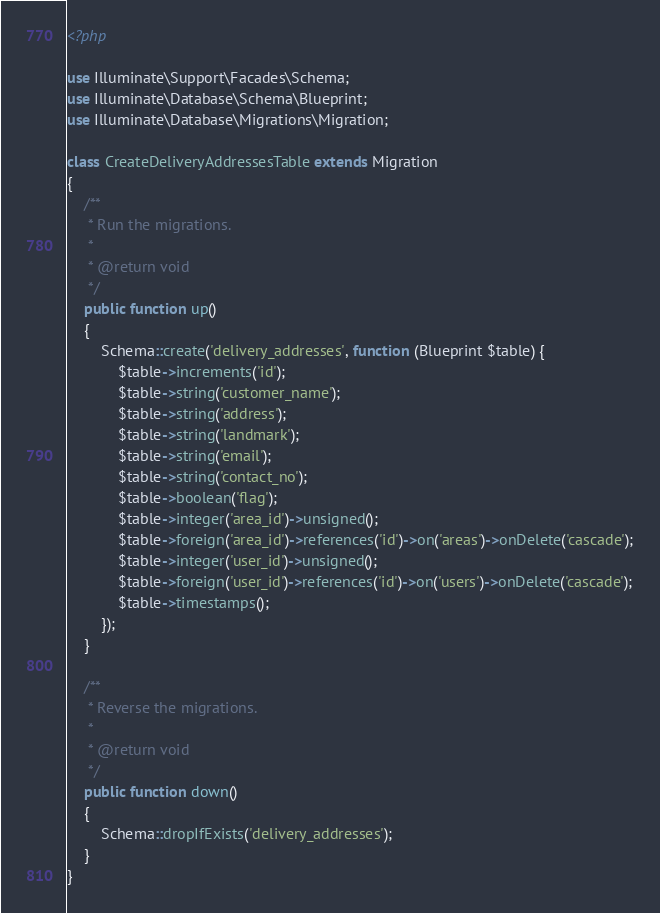<code> <loc_0><loc_0><loc_500><loc_500><_PHP_><?php

use Illuminate\Support\Facades\Schema;
use Illuminate\Database\Schema\Blueprint;
use Illuminate\Database\Migrations\Migration;

class CreateDeliveryAddressesTable extends Migration
{
    /**
     * Run the migrations.
     *
     * @return void
     */
    public function up()
    {
        Schema::create('delivery_addresses', function (Blueprint $table) {
            $table->increments('id');
            $table->string('customer_name');
            $table->string('address');
            $table->string('landmark');
            $table->string('email');
            $table->string('contact_no');
            $table->boolean('flag');
            $table->integer('area_id')->unsigned();
            $table->foreign('area_id')->references('id')->on('areas')->onDelete('cascade');
            $table->integer('user_id')->unsigned();
            $table->foreign('user_id')->references('id')->on('users')->onDelete('cascade');
            $table->timestamps();
        });
    }

    /**
     * Reverse the migrations.
     *
     * @return void
     */
    public function down()
    {
        Schema::dropIfExists('delivery_addresses');
    }
}
</code> 